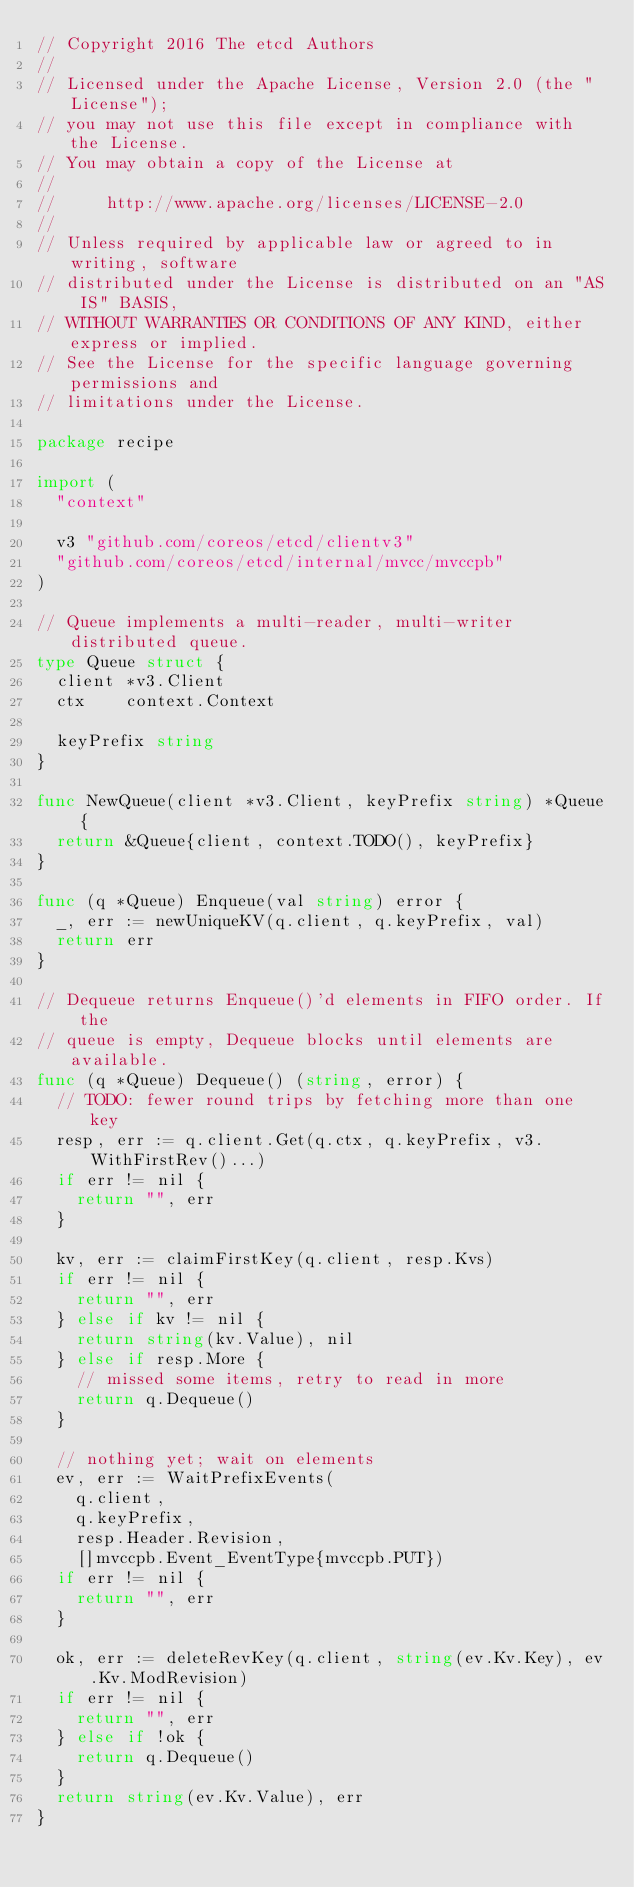<code> <loc_0><loc_0><loc_500><loc_500><_Go_>// Copyright 2016 The etcd Authors
//
// Licensed under the Apache License, Version 2.0 (the "License");
// you may not use this file except in compliance with the License.
// You may obtain a copy of the License at
//
//     http://www.apache.org/licenses/LICENSE-2.0
//
// Unless required by applicable law or agreed to in writing, software
// distributed under the License is distributed on an "AS IS" BASIS,
// WITHOUT WARRANTIES OR CONDITIONS OF ANY KIND, either express or implied.
// See the License for the specific language governing permissions and
// limitations under the License.

package recipe

import (
	"context"

	v3 "github.com/coreos/etcd/clientv3"
	"github.com/coreos/etcd/internal/mvcc/mvccpb"
)

// Queue implements a multi-reader, multi-writer distributed queue.
type Queue struct {
	client *v3.Client
	ctx    context.Context

	keyPrefix string
}

func NewQueue(client *v3.Client, keyPrefix string) *Queue {
	return &Queue{client, context.TODO(), keyPrefix}
}

func (q *Queue) Enqueue(val string) error {
	_, err := newUniqueKV(q.client, q.keyPrefix, val)
	return err
}

// Dequeue returns Enqueue()'d elements in FIFO order. If the
// queue is empty, Dequeue blocks until elements are available.
func (q *Queue) Dequeue() (string, error) {
	// TODO: fewer round trips by fetching more than one key
	resp, err := q.client.Get(q.ctx, q.keyPrefix, v3.WithFirstRev()...)
	if err != nil {
		return "", err
	}

	kv, err := claimFirstKey(q.client, resp.Kvs)
	if err != nil {
		return "", err
	} else if kv != nil {
		return string(kv.Value), nil
	} else if resp.More {
		// missed some items, retry to read in more
		return q.Dequeue()
	}

	// nothing yet; wait on elements
	ev, err := WaitPrefixEvents(
		q.client,
		q.keyPrefix,
		resp.Header.Revision,
		[]mvccpb.Event_EventType{mvccpb.PUT})
	if err != nil {
		return "", err
	}

	ok, err := deleteRevKey(q.client, string(ev.Kv.Key), ev.Kv.ModRevision)
	if err != nil {
		return "", err
	} else if !ok {
		return q.Dequeue()
	}
	return string(ev.Kv.Value), err
}
</code> 